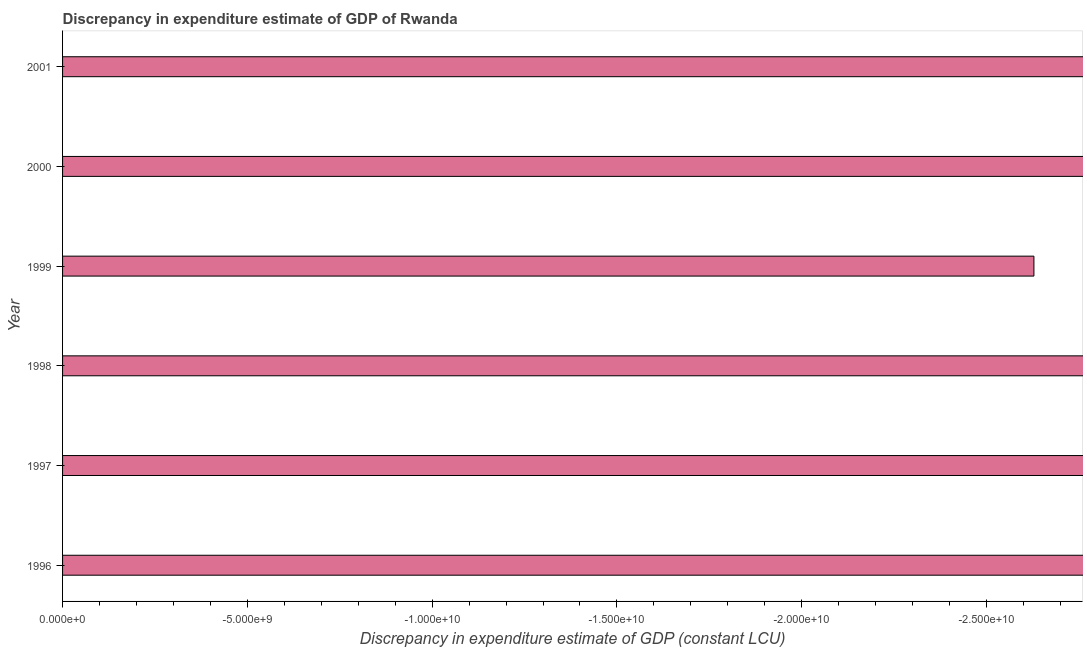Does the graph contain any zero values?
Keep it short and to the point. Yes. What is the title of the graph?
Provide a succinct answer. Discrepancy in expenditure estimate of GDP of Rwanda. What is the label or title of the X-axis?
Make the answer very short. Discrepancy in expenditure estimate of GDP (constant LCU). What is the sum of the discrepancy in expenditure estimate of gdp?
Offer a very short reply. 0. What is the average discrepancy in expenditure estimate of gdp per year?
Give a very brief answer. 0. What is the median discrepancy in expenditure estimate of gdp?
Offer a very short reply. 0. In how many years, is the discrepancy in expenditure estimate of gdp greater than -23000000000 LCU?
Your answer should be very brief. 0. How many years are there in the graph?
Keep it short and to the point. 6. What is the difference between two consecutive major ticks on the X-axis?
Offer a terse response. 5.00e+09. Are the values on the major ticks of X-axis written in scientific E-notation?
Your answer should be compact. Yes. What is the Discrepancy in expenditure estimate of GDP (constant LCU) in 1996?
Offer a very short reply. 0. What is the Discrepancy in expenditure estimate of GDP (constant LCU) of 1997?
Make the answer very short. 0. 